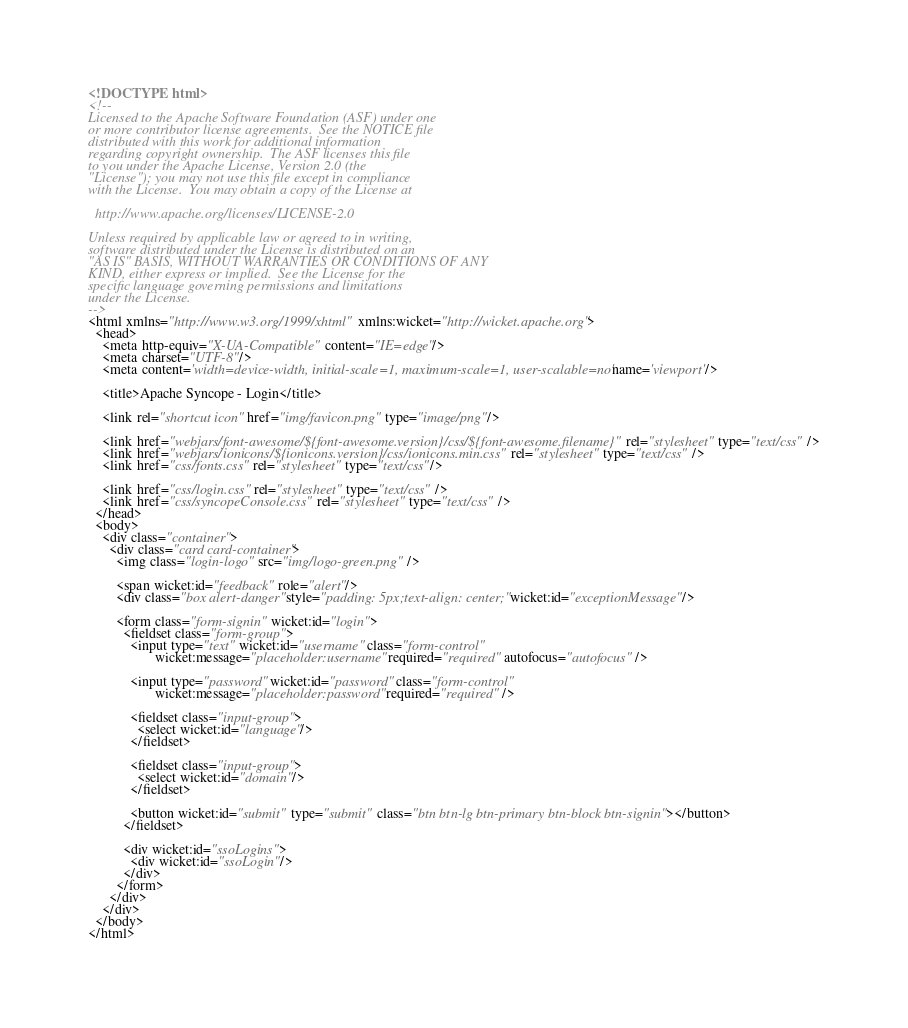Convert code to text. <code><loc_0><loc_0><loc_500><loc_500><_HTML_><!DOCTYPE html>
<!--
Licensed to the Apache Software Foundation (ASF) under one
or more contributor license agreements.  See the NOTICE file
distributed with this work for additional information
regarding copyright ownership.  The ASF licenses this file
to you under the Apache License, Version 2.0 (the
"License"); you may not use this file except in compliance
with the License.  You may obtain a copy of the License at

  http://www.apache.org/licenses/LICENSE-2.0

Unless required by applicable law or agreed to in writing,
software distributed under the License is distributed on an
"AS IS" BASIS, WITHOUT WARRANTIES OR CONDITIONS OF ANY
KIND, either express or implied.  See the License for the
specific language governing permissions and limitations
under the License.
-->
<html xmlns="http://www.w3.org/1999/xhtml" xmlns:wicket="http://wicket.apache.org">
  <head>
    <meta http-equiv="X-UA-Compatible" content="IE=edge"/>
    <meta charset="UTF-8"/>
    <meta content='width=device-width, initial-scale=1, maximum-scale=1, user-scalable=no' name='viewport'/>

    <title>Apache Syncope - Login</title>

    <link rel="shortcut icon" href="img/favicon.png" type="image/png"/>

    <link href="webjars/font-awesome/${font-awesome.version}/css/${font-awesome.filename}" rel="stylesheet" type="text/css" />
    <link href="webjars/ionicons/${ionicons.version}/css/ionicons.min.css" rel="stylesheet" type="text/css" />
    <link href="css/fonts.css" rel="stylesheet" type="text/css"/>

    <link href="css/login.css" rel="stylesheet" type="text/css" />
    <link href="css/syncopeConsole.css" rel="stylesheet" type="text/css" />
  </head>
  <body>
    <div class="container">
      <div class="card card-container">
        <img class="login-logo" src="img/logo-green.png" />

        <span wicket:id="feedback" role="alert"/>
        <div class="box alert-danger" style="padding: 5px;text-align: center;" wicket:id="exceptionMessage"/>

        <form class="form-signin" wicket:id="login">
          <fieldset class="form-group">
            <input type="text" wicket:id="username" class="form-control" 
                   wicket:message="placeholder:username" required="required" autofocus="autofocus" />

            <input type="password" wicket:id="password" class="form-control" 
                   wicket:message="placeholder:password" required="required" />

            <fieldset class="input-group">
              <select wicket:id="language"/>
            </fieldset>

            <fieldset class="input-group">
              <select wicket:id="domain"/>
            </fieldset>

            <button wicket:id="submit" type="submit" class="btn btn-lg btn-primary btn-block btn-signin"></button>
          </fieldset>

          <div wicket:id="ssoLogins">
            <div wicket:id="ssoLogin"/>
          </div>
        </form>
      </div>
    </div>
  </body>
</html></code> 